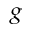<formula> <loc_0><loc_0><loc_500><loc_500>^ { g }</formula> 